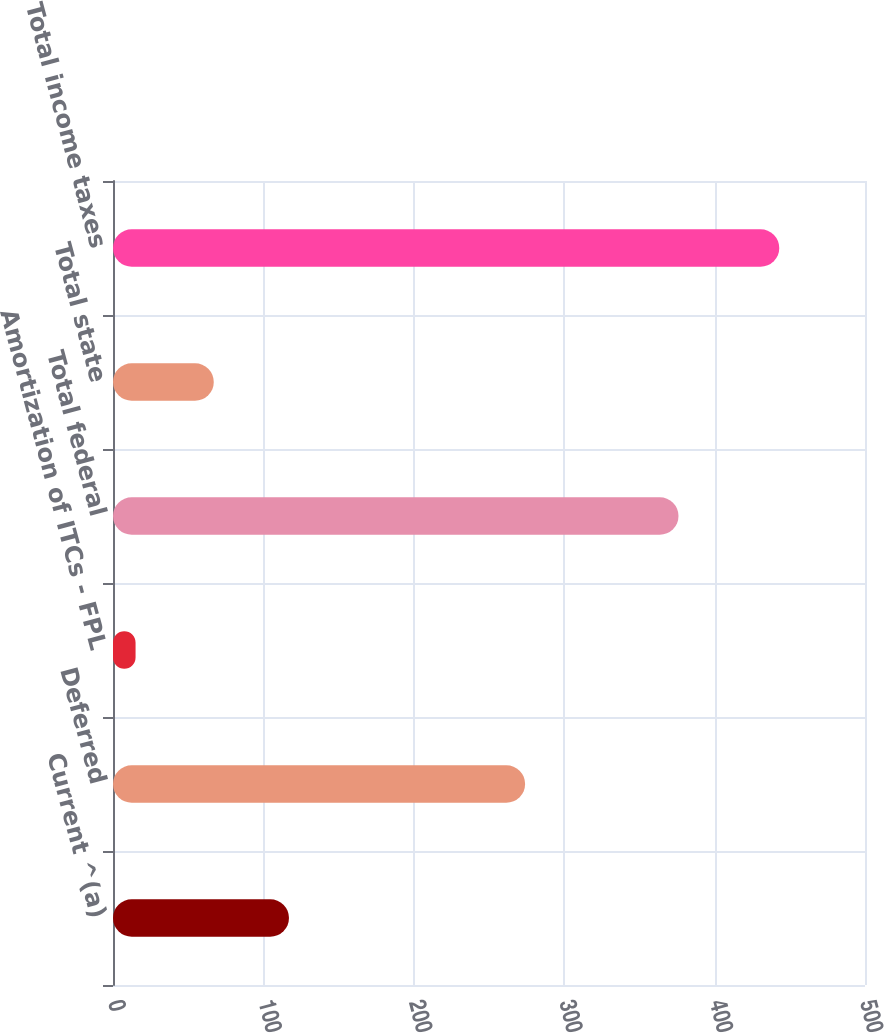Convert chart to OTSL. <chart><loc_0><loc_0><loc_500><loc_500><bar_chart><fcel>Current ^(a)<fcel>Deferred<fcel>Amortization of ITCs - FPL<fcel>Total federal<fcel>Total state<fcel>Total income taxes<nl><fcel>117<fcel>274<fcel>15<fcel>376<fcel>67<fcel>443<nl></chart> 